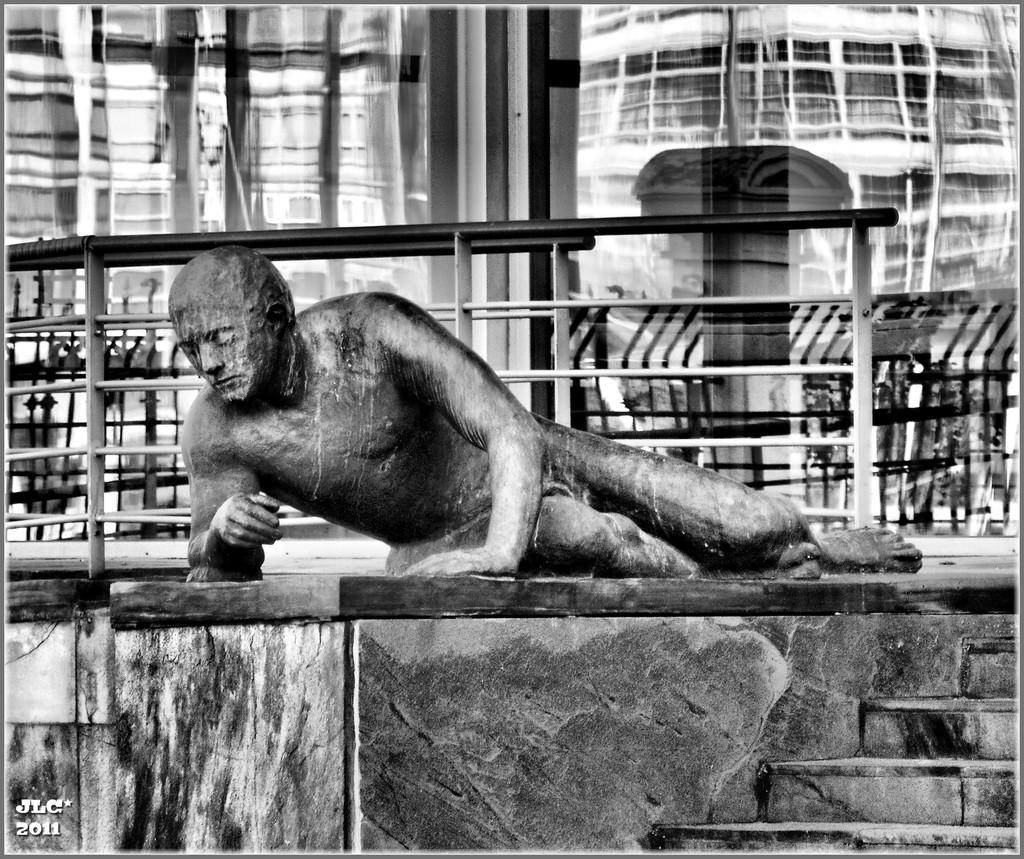What is the color scheme of the image? The image is black and white. What is the main subject in the foreground of the image? There is a sculpture in the foreground of the image. What can be seen in the background of the image? There are buildings, a railing, and glass windows in the background of the image. Can you see a locket hanging from the sculpture in the image? There is no locket visible on the sculpture in the image. Is there a boat sailing in the background of the image? There is no boat present in the image; it features a sculpture in the foreground and buildings, a railing, and glass windows in the background. 